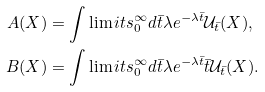<formula> <loc_0><loc_0><loc_500><loc_500>A ( X ) & = \int \lim i t s _ { 0 } ^ { \infty } d \bar { t } \lambda e ^ { - \lambda \bar { t } } \mathcal { U } _ { \bar { t } } ( X ) , \\ B ( X ) & = \int \lim i t s _ { 0 } ^ { \infty } d \bar { t } \lambda e ^ { - \lambda \bar { t } } \bar { t } \mathcal { U } _ { \bar { t } } ( X ) .</formula> 